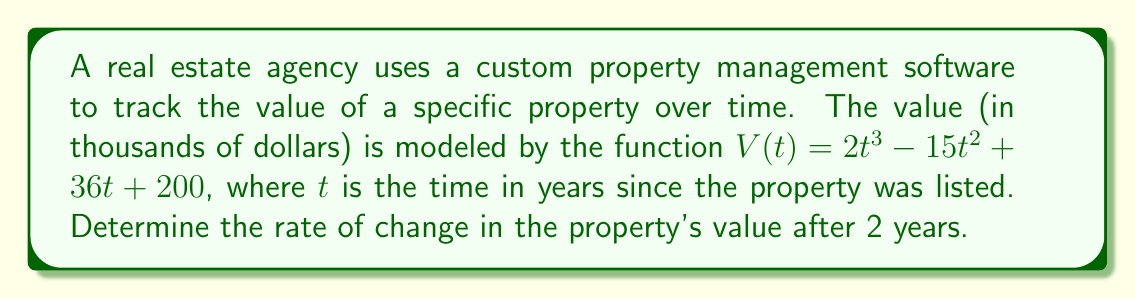Show me your answer to this math problem. To find the rate of change in the property's value after 2 years, we need to follow these steps:

1. Identify the function for the property value:
   $V(t) = 2t^3 - 15t^2 + 36t + 200$

2. Calculate the derivative of $V(t)$ to get the rate of change function:
   $$\frac{dV}{dt} = V'(t) = 6t^2 - 30t + 36$$

3. Evaluate the derivative at $t = 2$ years:
   $$V'(2) = 6(2)^2 - 30(2) + 36$$
   $$V'(2) = 6(4) - 60 + 36$$
   $$V'(2) = 24 - 60 + 36$$
   $$V'(2) = 0$$

The rate of change is measured in thousands of dollars per year, so we need to interpret this result accordingly.
Answer: $0$ thousand dollars per year 